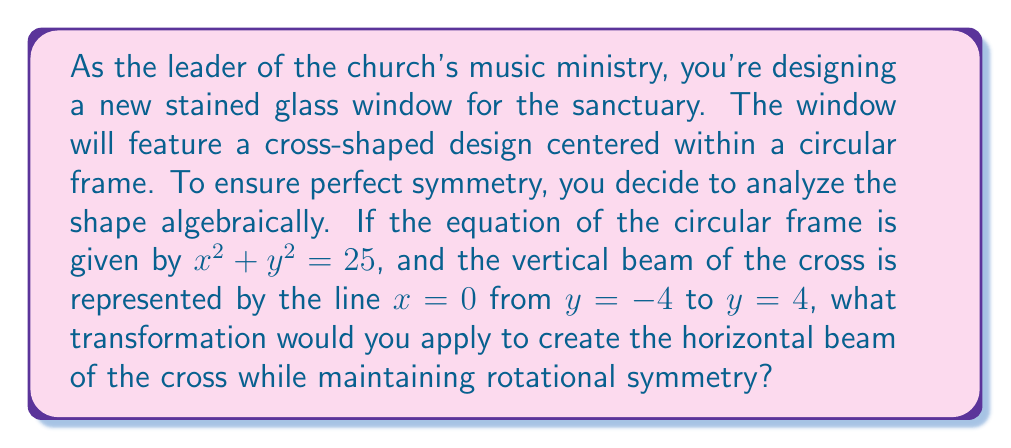Help me with this question. Let's approach this step-by-step:

1) The circular frame is represented by $x^2 + y^2 = 25$, which is a circle centered at the origin with radius 5.

2) The vertical beam of the cross is already given by $x = 0$ from $y = -4$ to $y = 4$.

3) To maintain rotational symmetry, the horizontal beam should be perpendicular to the vertical beam and have the same length.

4) The transformation we need is a 90-degree rotation about the origin. In algebraic terms, this is represented by the transformation:

   $$(x, y) \rightarrow (-y, x)$$

5) Applying this transformation to the equation of the vertical beam $x = 0$:
   
   Original equation: $x = 0$
   Transformed equation: $y = 0$

6) The limits should also be rotated. The original y-limits of -4 to 4 will become the x-limits for the horizontal beam.

Therefore, the horizontal beam will be represented by the line $y = 0$ from $x = -4$ to $x = 4$.

This transformation ensures that the cross maintains perfect rotational symmetry within the circular frame.
Answer: 90-degree rotation: $(x, y) \rightarrow (-y, x)$ 